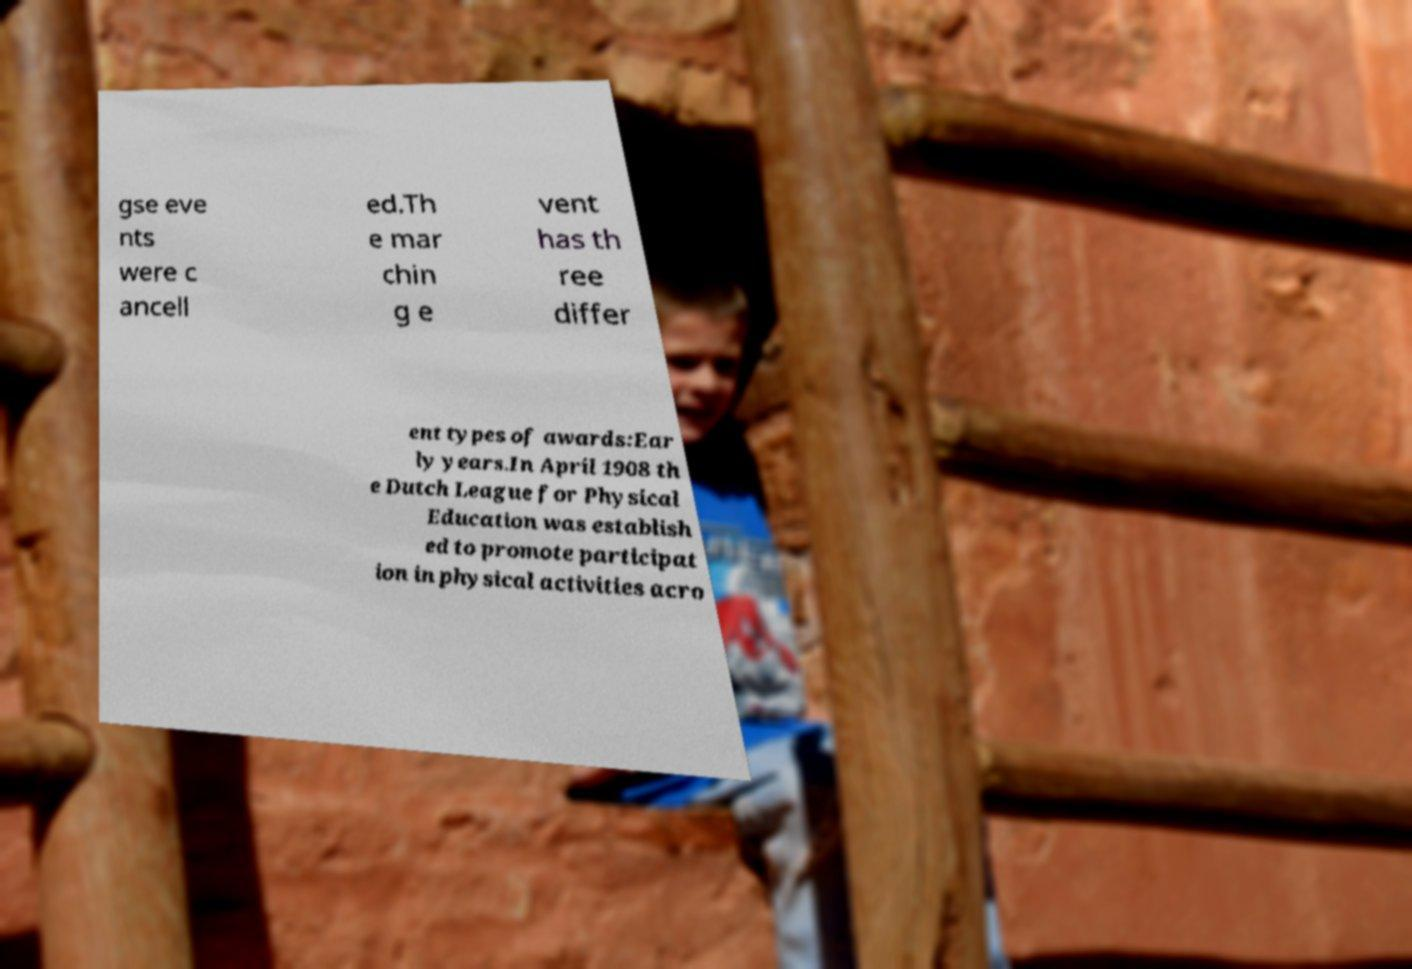Can you read and provide the text displayed in the image?This photo seems to have some interesting text. Can you extract and type it out for me? gse eve nts were c ancell ed.Th e mar chin g e vent has th ree differ ent types of awards:Ear ly years.In April 1908 th e Dutch League for Physical Education was establish ed to promote participat ion in physical activities acro 